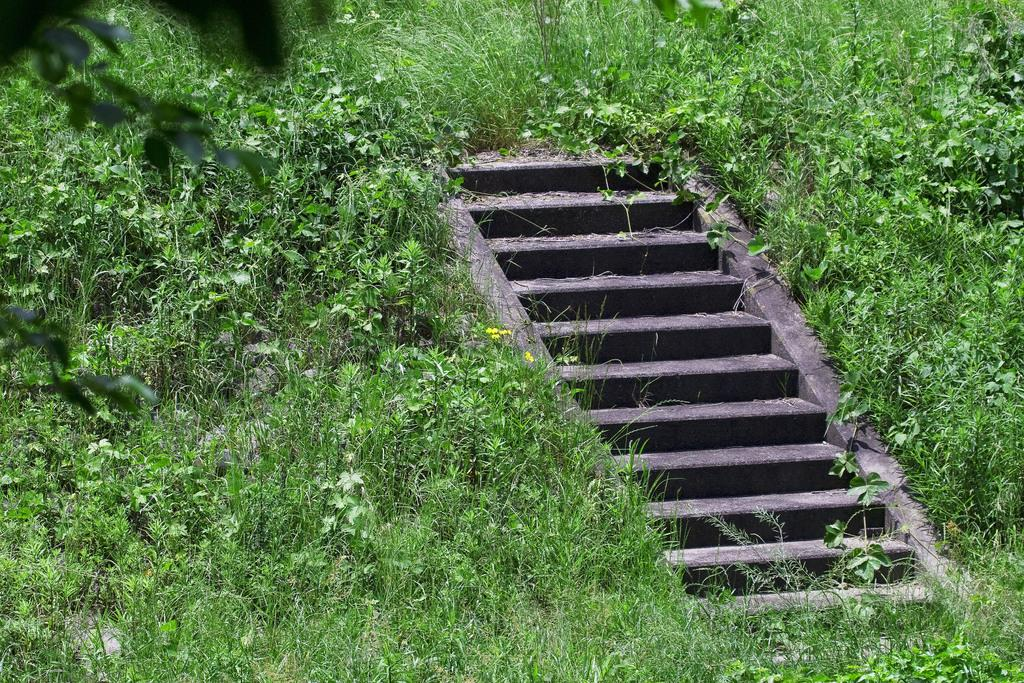What type of structure is in the middle of the ground in the image? There are cement steps in the middle of the ground in the image. What can be seen growing near the cement steps? There are small plants and grass in the image. Where is the grass located in relation to the cement steps? The grass is around the cement steps. Can you tell me how the zephyr is helping the small plants grow in the image? There is no mention of a zephyr in the image, so it cannot be determined how it might be helping the small plants grow. 